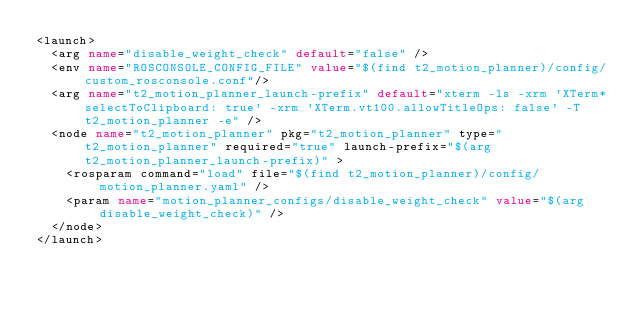<code> <loc_0><loc_0><loc_500><loc_500><_XML_><launch>
  <arg name="disable_weight_check" default="false" />
  <env name="ROSCONSOLE_CONFIG_FILE" value="$(find t2_motion_planner)/config/custom_rosconsole.conf"/>
  <arg name="t2_motion_planner_launch-prefix" default="xterm -ls -xrm 'XTerm*selectToClipboard: true' -xrm 'XTerm.vt100.allowTitleOps: false' -T t2_motion_planner -e" />
  <node name="t2_motion_planner" pkg="t2_motion_planner" type="t2_motion_planner" required="true" launch-prefix="$(arg t2_motion_planner_launch-prefix)" >
    <rosparam command="load" file="$(find t2_motion_planner)/config/motion_planner.yaml" />
    <param name="motion_planner_configs/disable_weight_check" value="$(arg disable_weight_check)" />
  </node>
</launch>
</code> 